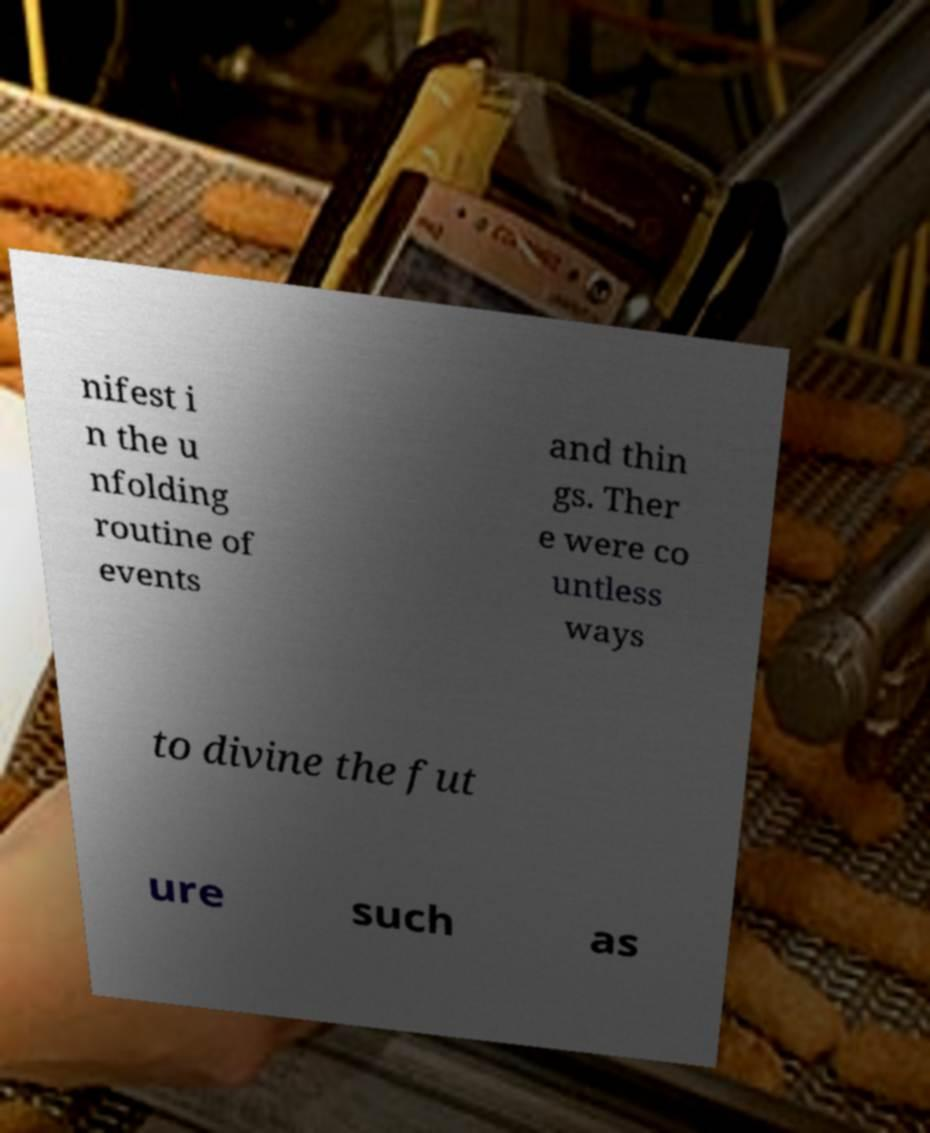Could you extract and type out the text from this image? nifest i n the u nfolding routine of events and thin gs. Ther e were co untless ways to divine the fut ure such as 